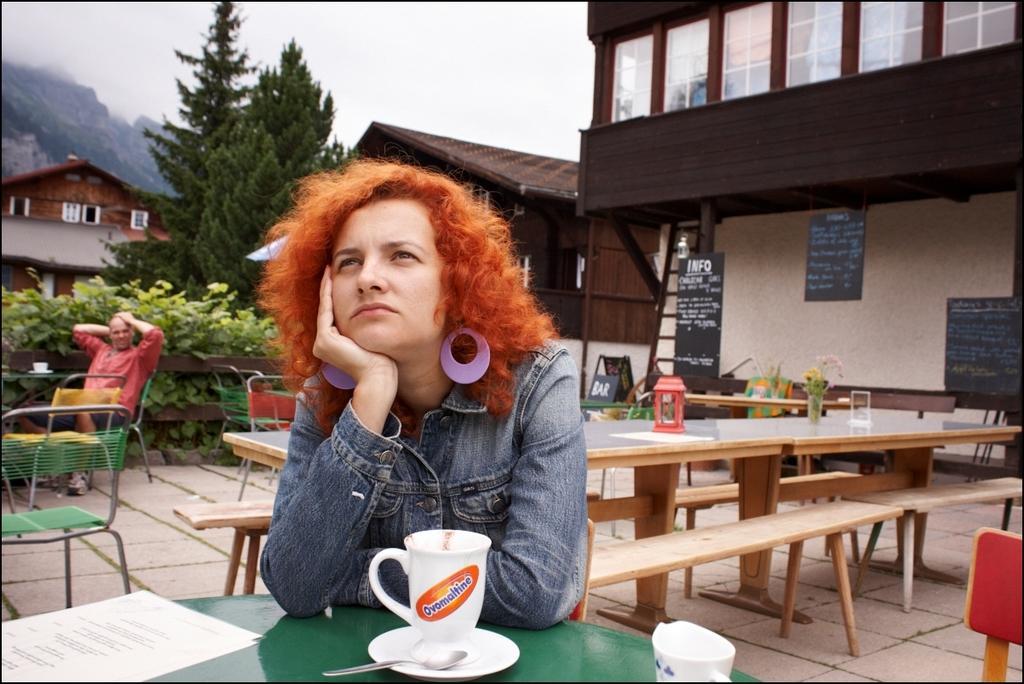Could you give a brief overview of what you see in this image? a person is sitting on a chair. in front of her there is a green table on which there is a cup, saucer, spoon and a paper. she is wearing a denim jacket and has orange hair. behind her at the left there are green chairs and a person wearing red t shirt is seated on the chair. at the right there are tables and wooden tables. on the table there are glass and flower pot. at the left back there is a wooden fencing and plants. at the right there are blackboards and a building. at the back there is a tree, buildings and mountains. 